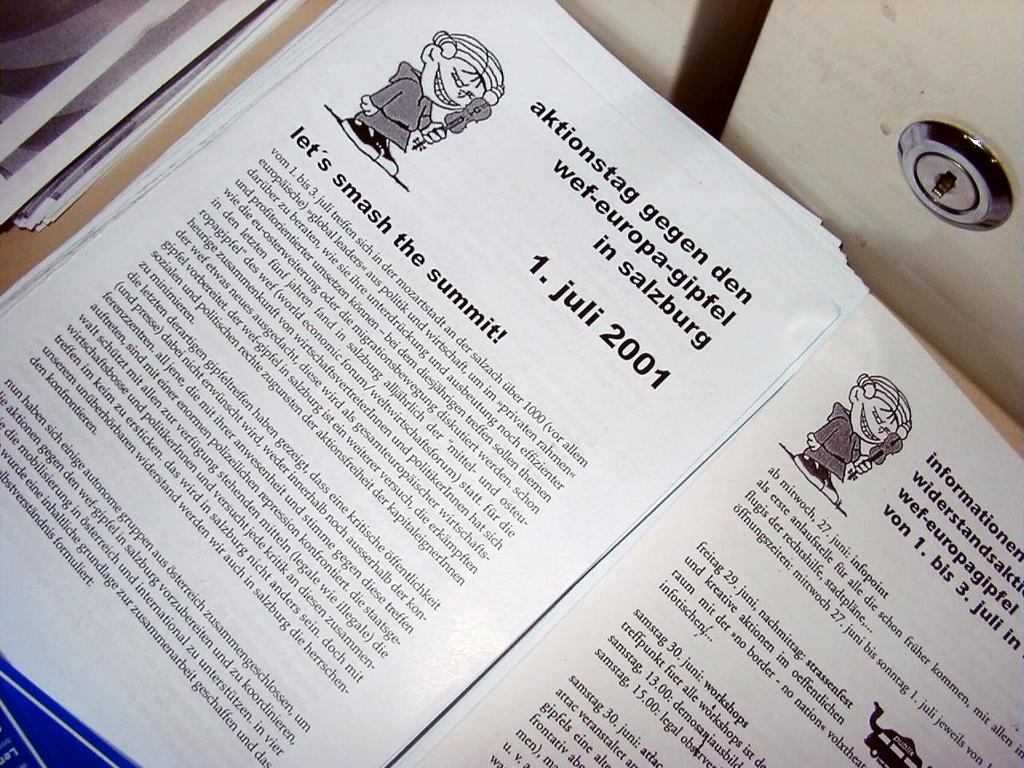<image>
Write a terse but informative summary of the picture. The pages of an open book with a paragraph entitled "Lets smash the summit!". 